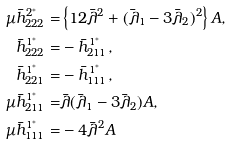Convert formula to latex. <formula><loc_0><loc_0><loc_500><loc_500>\mu \bar { h } _ { 2 2 2 } ^ { 2 ^ { * } } = & \left \{ 1 2 \bar { \lambda } ^ { 2 } + ( \bar { \lambda } _ { 1 } - 3 \bar { \lambda } _ { 2 } ) ^ { 2 } \right \} A , \\ \bar { h } _ { 2 2 2 } ^ { 1 ^ { * } } = & - \bar { h } _ { 2 1 1 } ^ { 1 ^ { * } } , \\ \bar { h } _ { 2 2 1 } ^ { 1 ^ { * } } = & - \bar { h } _ { 1 1 1 } ^ { 1 ^ { * } } , \\ \mu \bar { h } _ { 2 1 1 } ^ { 1 ^ { * } } = & \bar { \lambda } ( \bar { \lambda } _ { 1 } - 3 \bar { \lambda } _ { 2 } ) A , \\ \mu \bar { h } _ { 1 1 1 } ^ { 1 ^ { * } } = & - 4 \bar { \lambda } ^ { 2 } A \\</formula> 